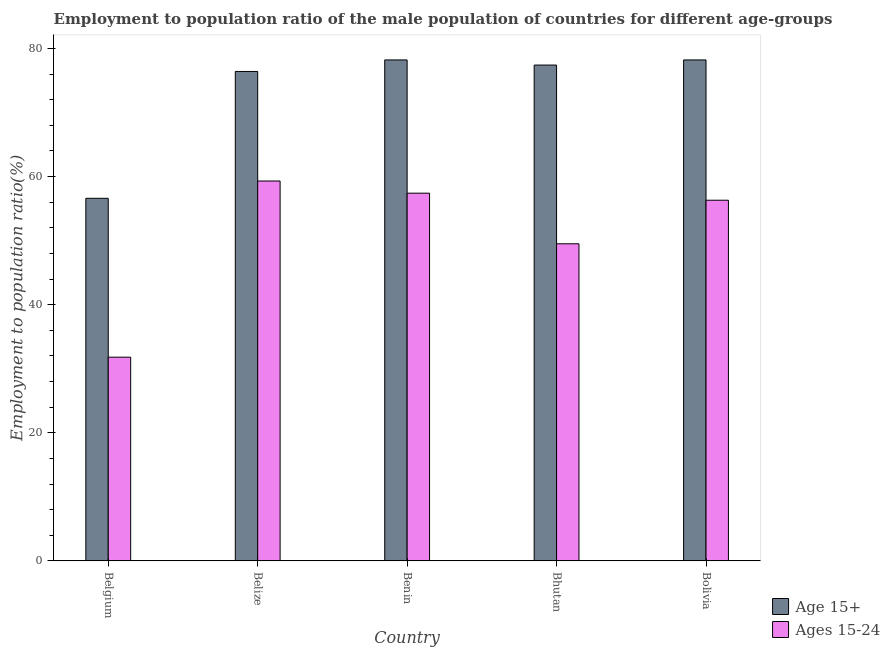How many different coloured bars are there?
Give a very brief answer. 2. How many groups of bars are there?
Offer a terse response. 5. Are the number of bars per tick equal to the number of legend labels?
Ensure brevity in your answer.  Yes. What is the label of the 4th group of bars from the left?
Give a very brief answer. Bhutan. In how many cases, is the number of bars for a given country not equal to the number of legend labels?
Provide a succinct answer. 0. What is the employment to population ratio(age 15+) in Belize?
Your answer should be very brief. 76.4. Across all countries, what is the maximum employment to population ratio(age 15-24)?
Make the answer very short. 59.3. Across all countries, what is the minimum employment to population ratio(age 15+)?
Provide a succinct answer. 56.6. In which country was the employment to population ratio(age 15-24) maximum?
Offer a terse response. Belize. What is the total employment to population ratio(age 15-24) in the graph?
Offer a very short reply. 254.3. What is the difference between the employment to population ratio(age 15+) in Belize and that in Bolivia?
Offer a very short reply. -1.8. What is the difference between the employment to population ratio(age 15-24) in Bolivia and the employment to population ratio(age 15+) in Benin?
Provide a succinct answer. -21.9. What is the average employment to population ratio(age 15-24) per country?
Give a very brief answer. 50.86. What is the difference between the employment to population ratio(age 15-24) and employment to population ratio(age 15+) in Benin?
Make the answer very short. -20.8. What is the ratio of the employment to population ratio(age 15-24) in Belgium to that in Benin?
Your response must be concise. 0.55. Is the difference between the employment to population ratio(age 15+) in Belize and Bhutan greater than the difference between the employment to population ratio(age 15-24) in Belize and Bhutan?
Your answer should be very brief. No. What is the difference between the highest and the second highest employment to population ratio(age 15-24)?
Your response must be concise. 1.9. What is the difference between the highest and the lowest employment to population ratio(age 15+)?
Your answer should be compact. 21.6. Is the sum of the employment to population ratio(age 15-24) in Belize and Bhutan greater than the maximum employment to population ratio(age 15+) across all countries?
Provide a succinct answer. Yes. What does the 2nd bar from the left in Benin represents?
Offer a very short reply. Ages 15-24. What does the 2nd bar from the right in Bhutan represents?
Provide a succinct answer. Age 15+. How many bars are there?
Ensure brevity in your answer.  10. Are all the bars in the graph horizontal?
Make the answer very short. No. How many countries are there in the graph?
Offer a very short reply. 5. Are the values on the major ticks of Y-axis written in scientific E-notation?
Provide a short and direct response. No. Does the graph contain any zero values?
Offer a terse response. No. Does the graph contain grids?
Your answer should be very brief. No. Where does the legend appear in the graph?
Keep it short and to the point. Bottom right. What is the title of the graph?
Ensure brevity in your answer.  Employment to population ratio of the male population of countries for different age-groups. Does "Age 65(female)" appear as one of the legend labels in the graph?
Your answer should be very brief. No. What is the label or title of the X-axis?
Offer a very short reply. Country. What is the label or title of the Y-axis?
Offer a terse response. Employment to population ratio(%). What is the Employment to population ratio(%) in Age 15+ in Belgium?
Your answer should be compact. 56.6. What is the Employment to population ratio(%) in Ages 15-24 in Belgium?
Provide a short and direct response. 31.8. What is the Employment to population ratio(%) of Age 15+ in Belize?
Your response must be concise. 76.4. What is the Employment to population ratio(%) in Ages 15-24 in Belize?
Offer a terse response. 59.3. What is the Employment to population ratio(%) in Age 15+ in Benin?
Offer a terse response. 78.2. What is the Employment to population ratio(%) of Ages 15-24 in Benin?
Your response must be concise. 57.4. What is the Employment to population ratio(%) in Age 15+ in Bhutan?
Provide a short and direct response. 77.4. What is the Employment to population ratio(%) of Ages 15-24 in Bhutan?
Ensure brevity in your answer.  49.5. What is the Employment to population ratio(%) in Age 15+ in Bolivia?
Ensure brevity in your answer.  78.2. What is the Employment to population ratio(%) of Ages 15-24 in Bolivia?
Make the answer very short. 56.3. Across all countries, what is the maximum Employment to population ratio(%) in Age 15+?
Give a very brief answer. 78.2. Across all countries, what is the maximum Employment to population ratio(%) of Ages 15-24?
Make the answer very short. 59.3. Across all countries, what is the minimum Employment to population ratio(%) in Age 15+?
Offer a very short reply. 56.6. Across all countries, what is the minimum Employment to population ratio(%) in Ages 15-24?
Offer a very short reply. 31.8. What is the total Employment to population ratio(%) in Age 15+ in the graph?
Provide a short and direct response. 366.8. What is the total Employment to population ratio(%) of Ages 15-24 in the graph?
Ensure brevity in your answer.  254.3. What is the difference between the Employment to population ratio(%) in Age 15+ in Belgium and that in Belize?
Provide a short and direct response. -19.8. What is the difference between the Employment to population ratio(%) of Ages 15-24 in Belgium and that in Belize?
Your answer should be very brief. -27.5. What is the difference between the Employment to population ratio(%) in Age 15+ in Belgium and that in Benin?
Give a very brief answer. -21.6. What is the difference between the Employment to population ratio(%) of Ages 15-24 in Belgium and that in Benin?
Your answer should be very brief. -25.6. What is the difference between the Employment to population ratio(%) of Age 15+ in Belgium and that in Bhutan?
Give a very brief answer. -20.8. What is the difference between the Employment to population ratio(%) of Ages 15-24 in Belgium and that in Bhutan?
Offer a terse response. -17.7. What is the difference between the Employment to population ratio(%) in Age 15+ in Belgium and that in Bolivia?
Ensure brevity in your answer.  -21.6. What is the difference between the Employment to population ratio(%) of Ages 15-24 in Belgium and that in Bolivia?
Give a very brief answer. -24.5. What is the difference between the Employment to population ratio(%) of Age 15+ in Benin and that in Bhutan?
Offer a terse response. 0.8. What is the difference between the Employment to population ratio(%) in Ages 15-24 in Benin and that in Bhutan?
Your response must be concise. 7.9. What is the difference between the Employment to population ratio(%) in Age 15+ in Benin and that in Bolivia?
Keep it short and to the point. 0. What is the difference between the Employment to population ratio(%) in Ages 15-24 in Benin and that in Bolivia?
Offer a terse response. 1.1. What is the difference between the Employment to population ratio(%) in Age 15+ in Belgium and the Employment to population ratio(%) in Ages 15-24 in Belize?
Offer a terse response. -2.7. What is the difference between the Employment to population ratio(%) of Age 15+ in Belize and the Employment to population ratio(%) of Ages 15-24 in Benin?
Ensure brevity in your answer.  19. What is the difference between the Employment to population ratio(%) in Age 15+ in Belize and the Employment to population ratio(%) in Ages 15-24 in Bhutan?
Make the answer very short. 26.9. What is the difference between the Employment to population ratio(%) in Age 15+ in Belize and the Employment to population ratio(%) in Ages 15-24 in Bolivia?
Give a very brief answer. 20.1. What is the difference between the Employment to population ratio(%) of Age 15+ in Benin and the Employment to population ratio(%) of Ages 15-24 in Bhutan?
Ensure brevity in your answer.  28.7. What is the difference between the Employment to population ratio(%) of Age 15+ in Benin and the Employment to population ratio(%) of Ages 15-24 in Bolivia?
Provide a succinct answer. 21.9. What is the difference between the Employment to population ratio(%) of Age 15+ in Bhutan and the Employment to population ratio(%) of Ages 15-24 in Bolivia?
Your answer should be very brief. 21.1. What is the average Employment to population ratio(%) in Age 15+ per country?
Keep it short and to the point. 73.36. What is the average Employment to population ratio(%) in Ages 15-24 per country?
Offer a terse response. 50.86. What is the difference between the Employment to population ratio(%) of Age 15+ and Employment to population ratio(%) of Ages 15-24 in Belgium?
Keep it short and to the point. 24.8. What is the difference between the Employment to population ratio(%) in Age 15+ and Employment to population ratio(%) in Ages 15-24 in Belize?
Offer a terse response. 17.1. What is the difference between the Employment to population ratio(%) of Age 15+ and Employment to population ratio(%) of Ages 15-24 in Benin?
Provide a succinct answer. 20.8. What is the difference between the Employment to population ratio(%) of Age 15+ and Employment to population ratio(%) of Ages 15-24 in Bhutan?
Offer a terse response. 27.9. What is the difference between the Employment to population ratio(%) in Age 15+ and Employment to population ratio(%) in Ages 15-24 in Bolivia?
Give a very brief answer. 21.9. What is the ratio of the Employment to population ratio(%) in Age 15+ in Belgium to that in Belize?
Ensure brevity in your answer.  0.74. What is the ratio of the Employment to population ratio(%) in Ages 15-24 in Belgium to that in Belize?
Make the answer very short. 0.54. What is the ratio of the Employment to population ratio(%) of Age 15+ in Belgium to that in Benin?
Offer a terse response. 0.72. What is the ratio of the Employment to population ratio(%) of Ages 15-24 in Belgium to that in Benin?
Keep it short and to the point. 0.55. What is the ratio of the Employment to population ratio(%) of Age 15+ in Belgium to that in Bhutan?
Your answer should be compact. 0.73. What is the ratio of the Employment to population ratio(%) of Ages 15-24 in Belgium to that in Bhutan?
Give a very brief answer. 0.64. What is the ratio of the Employment to population ratio(%) in Age 15+ in Belgium to that in Bolivia?
Provide a succinct answer. 0.72. What is the ratio of the Employment to population ratio(%) in Ages 15-24 in Belgium to that in Bolivia?
Provide a short and direct response. 0.56. What is the ratio of the Employment to population ratio(%) in Ages 15-24 in Belize to that in Benin?
Offer a very short reply. 1.03. What is the ratio of the Employment to population ratio(%) in Age 15+ in Belize to that in Bhutan?
Your answer should be compact. 0.99. What is the ratio of the Employment to population ratio(%) in Ages 15-24 in Belize to that in Bhutan?
Make the answer very short. 1.2. What is the ratio of the Employment to population ratio(%) of Ages 15-24 in Belize to that in Bolivia?
Offer a very short reply. 1.05. What is the ratio of the Employment to population ratio(%) of Age 15+ in Benin to that in Bhutan?
Offer a terse response. 1.01. What is the ratio of the Employment to population ratio(%) in Ages 15-24 in Benin to that in Bhutan?
Offer a very short reply. 1.16. What is the ratio of the Employment to population ratio(%) in Age 15+ in Benin to that in Bolivia?
Make the answer very short. 1. What is the ratio of the Employment to population ratio(%) of Ages 15-24 in Benin to that in Bolivia?
Provide a short and direct response. 1.02. What is the ratio of the Employment to population ratio(%) of Age 15+ in Bhutan to that in Bolivia?
Your answer should be compact. 0.99. What is the ratio of the Employment to population ratio(%) of Ages 15-24 in Bhutan to that in Bolivia?
Provide a succinct answer. 0.88. What is the difference between the highest and the second highest Employment to population ratio(%) of Ages 15-24?
Give a very brief answer. 1.9. What is the difference between the highest and the lowest Employment to population ratio(%) of Age 15+?
Keep it short and to the point. 21.6. What is the difference between the highest and the lowest Employment to population ratio(%) of Ages 15-24?
Provide a succinct answer. 27.5. 